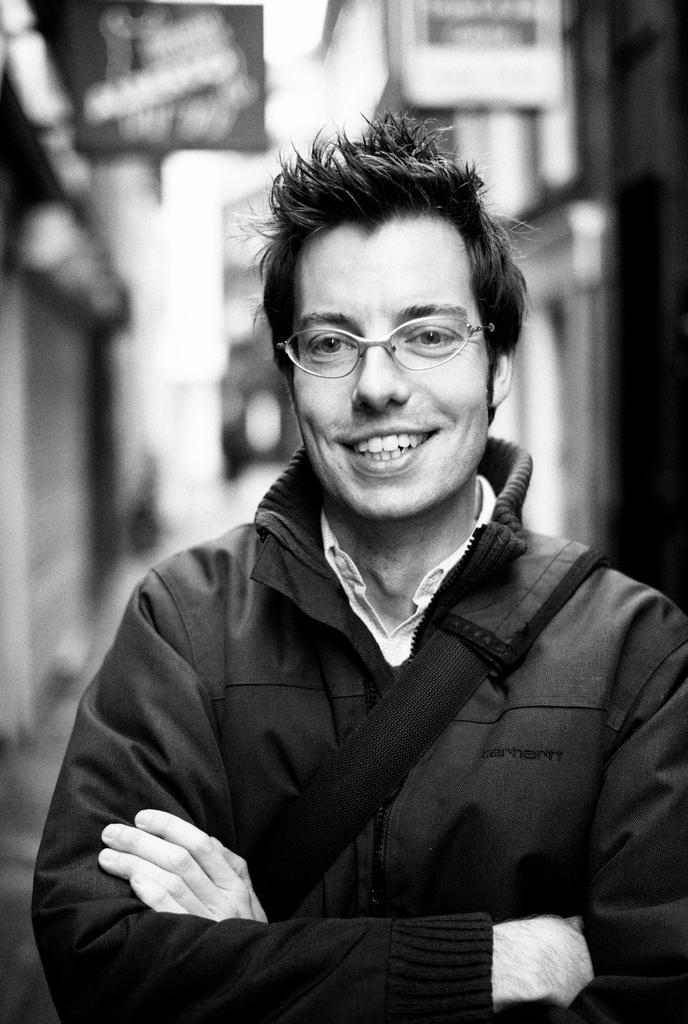In one or two sentences, can you explain what this image depicts? In this picture there is a man in the center standing and smiling and the background is blurry. 